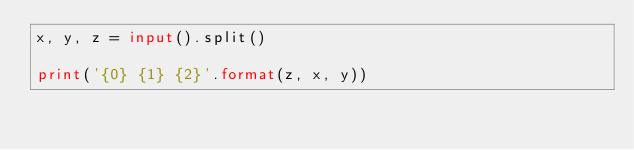Convert code to text. <code><loc_0><loc_0><loc_500><loc_500><_Python_>x, y, z = input().split()

print('{0} {1} {2}'.format(z, x, y))</code> 